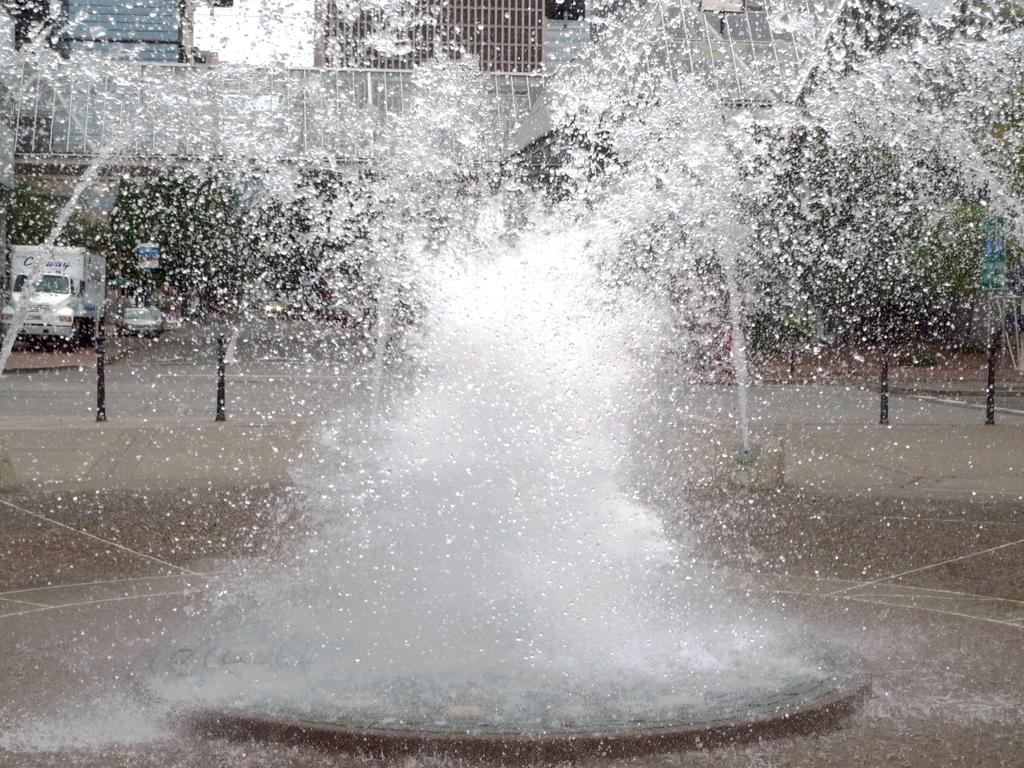What is visible in the image? Water is visible in the image. What can be seen in the background of the image? There are vehicles and buildings in the background of the image. Where is the doll located in the image? There is no doll present in the image. What type of map can be seen in the image? There is no map present in the image. 